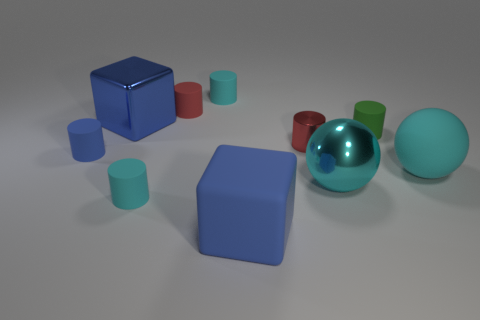Are there more green matte cylinders than large green metallic spheres?
Provide a short and direct response. Yes. There is a blue metallic object left of the red metal thing that is left of the tiny object that is to the right of the red metal object; how big is it?
Your answer should be compact. Large. What size is the cyan rubber object that is behind the tiny red metallic cylinder?
Make the answer very short. Small. How many things are either tiny green cubes or matte cylinders that are behind the blue rubber cube?
Provide a short and direct response. 5. How many other objects are the same size as the red metallic cylinder?
Keep it short and to the point. 5. What material is the other red object that is the same shape as the red rubber object?
Your answer should be very brief. Metal. Is the number of small cyan rubber cylinders in front of the cyan rubber ball greater than the number of large purple metallic balls?
Offer a very short reply. Yes. Is there any other thing that is the same color as the shiny ball?
Provide a succinct answer. Yes. What is the shape of the tiny red thing that is the same material as the tiny green cylinder?
Offer a very short reply. Cylinder. Do the tiny cyan cylinder that is in front of the matte sphere and the small blue thing have the same material?
Your response must be concise. Yes. 